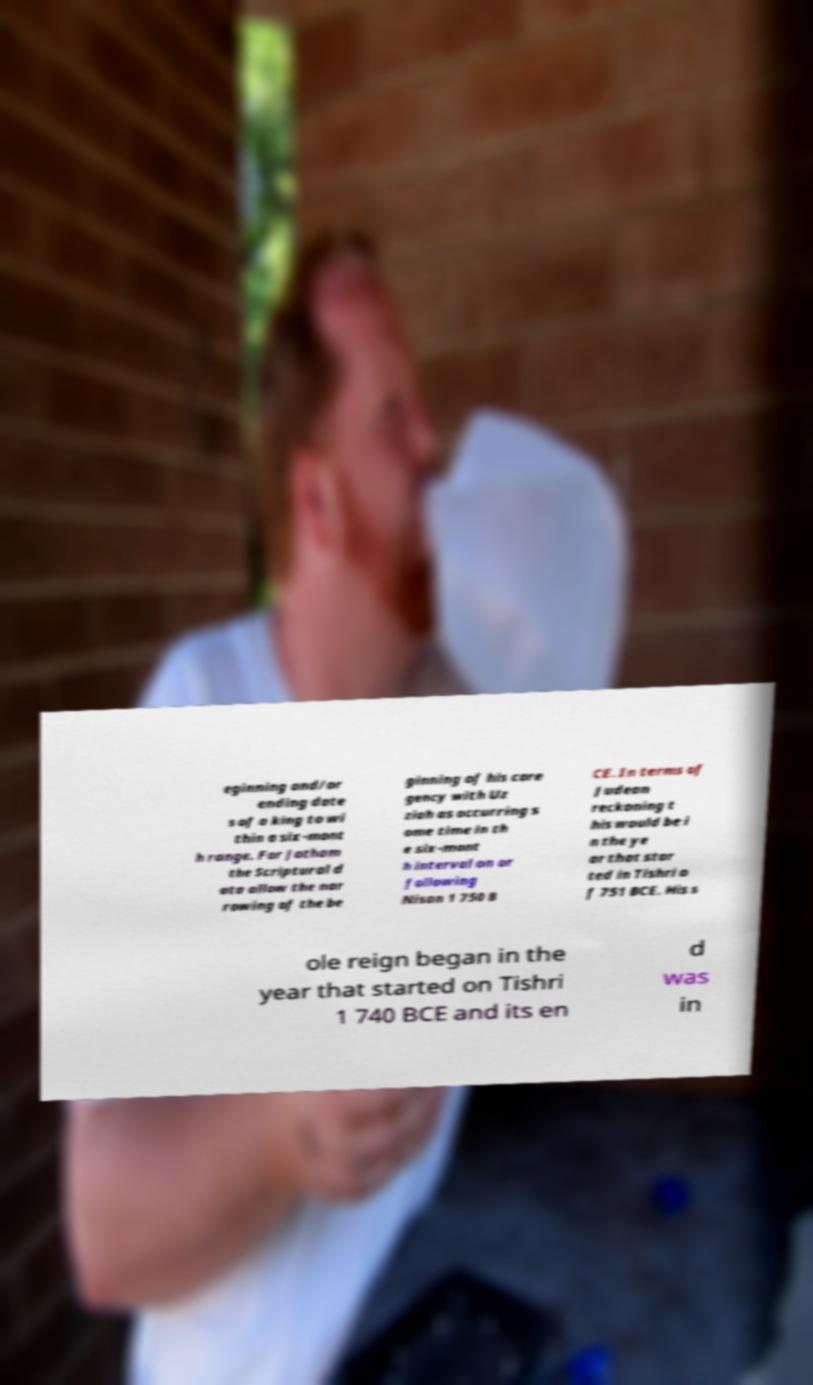What messages or text are displayed in this image? I need them in a readable, typed format. eginning and/or ending date s of a king to wi thin a six-mont h range. For Jotham the Scriptural d ata allow the nar rowing of the be ginning of his core gency with Uz ziah as occurring s ome time in th e six-mont h interval on or following Nisan 1 750 B CE. In terms of Judean reckoning t his would be i n the ye ar that star ted in Tishri o f 751 BCE. His s ole reign began in the year that started on Tishri 1 740 BCE and its en d was in 